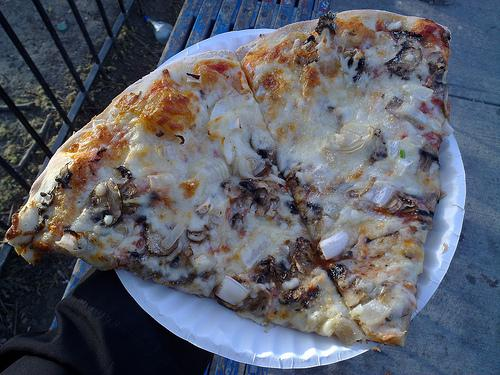Question: what is shining on the pizza?
Choices:
A. The light.
B. The moon.
C. The stars.
D. The sun.
Answer with the letter. Answer: D Question: where is the pizza?
Choices:
A. On a paper plate.
B. In the oven.
C. In a box.
D. In my stomach.
Answer with the letter. Answer: A Question: what is on the pizza?
Choices:
A. Mushrooms.
B. Sausage.
C. Pepperoni.
D. Cheese.
Answer with the letter. Answer: A Question: what color is the plate?
Choices:
A. Blue.
B. Red.
C. White.
D. Green.
Answer with the letter. Answer: C Question: what slice is bigger?
Choices:
A. The right hand slice.
B. The left-hand slice.
C. The slice on the table.
D. None of the slices.
Answer with the letter. Answer: B 